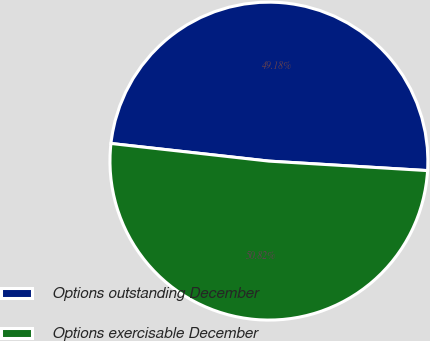Convert chart to OTSL. <chart><loc_0><loc_0><loc_500><loc_500><pie_chart><fcel>Options outstanding December<fcel>Options exercisable December<nl><fcel>49.18%<fcel>50.82%<nl></chart> 